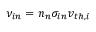<formula> <loc_0><loc_0><loc_500><loc_500>\nu _ { i n } = n _ { n } \sigma _ { i n } v _ { t h , i }</formula> 